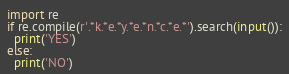<code> <loc_0><loc_0><loc_500><loc_500><_Python_>import re
if re.compile(r'.*k.*e.*y.*e.*n.*c.*e.*').search(input()):
  print('YES')
else:
  print('NO')</code> 